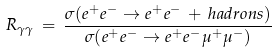<formula> <loc_0><loc_0><loc_500><loc_500>R _ { \gamma \gamma } \, = \, \frac { \sigma ( e ^ { + } e ^ { - } \rightarrow e ^ { + } e ^ { - } \, + \, h a d r o n s ) } { \sigma ( e ^ { + } e ^ { - } \rightarrow e ^ { + } e ^ { - } \mu ^ { + } \mu ^ { - } ) }</formula> 